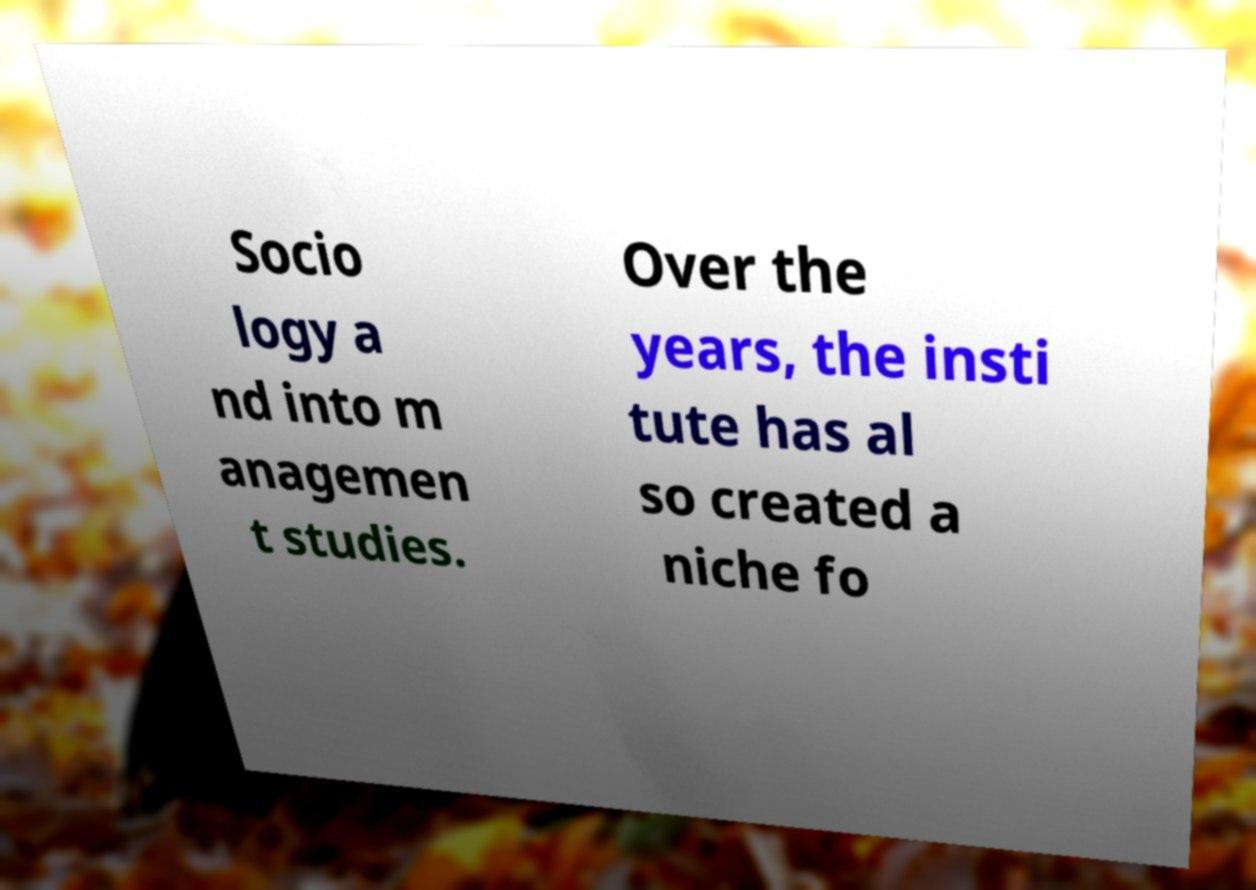For documentation purposes, I need the text within this image transcribed. Could you provide that? Socio logy a nd into m anagemen t studies. Over the years, the insti tute has al so created a niche fo 